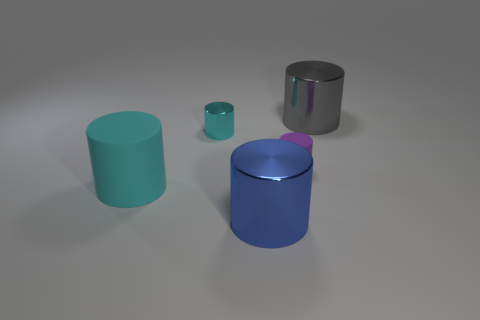Subtract all large blue metal cylinders. How many cylinders are left? 4 Subtract all purple blocks. How many cyan cylinders are left? 2 Subtract all purple cylinders. How many cylinders are left? 4 Subtract 4 cylinders. How many cylinders are left? 1 Subtract all brown cylinders. Subtract all gray balls. How many cylinders are left? 5 Add 3 yellow shiny cylinders. How many objects exist? 8 Subtract 0 gray cubes. How many objects are left? 5 Subtract all small cyan objects. Subtract all big matte cubes. How many objects are left? 4 Add 4 big cylinders. How many big cylinders are left? 7 Add 1 gray balls. How many gray balls exist? 1 